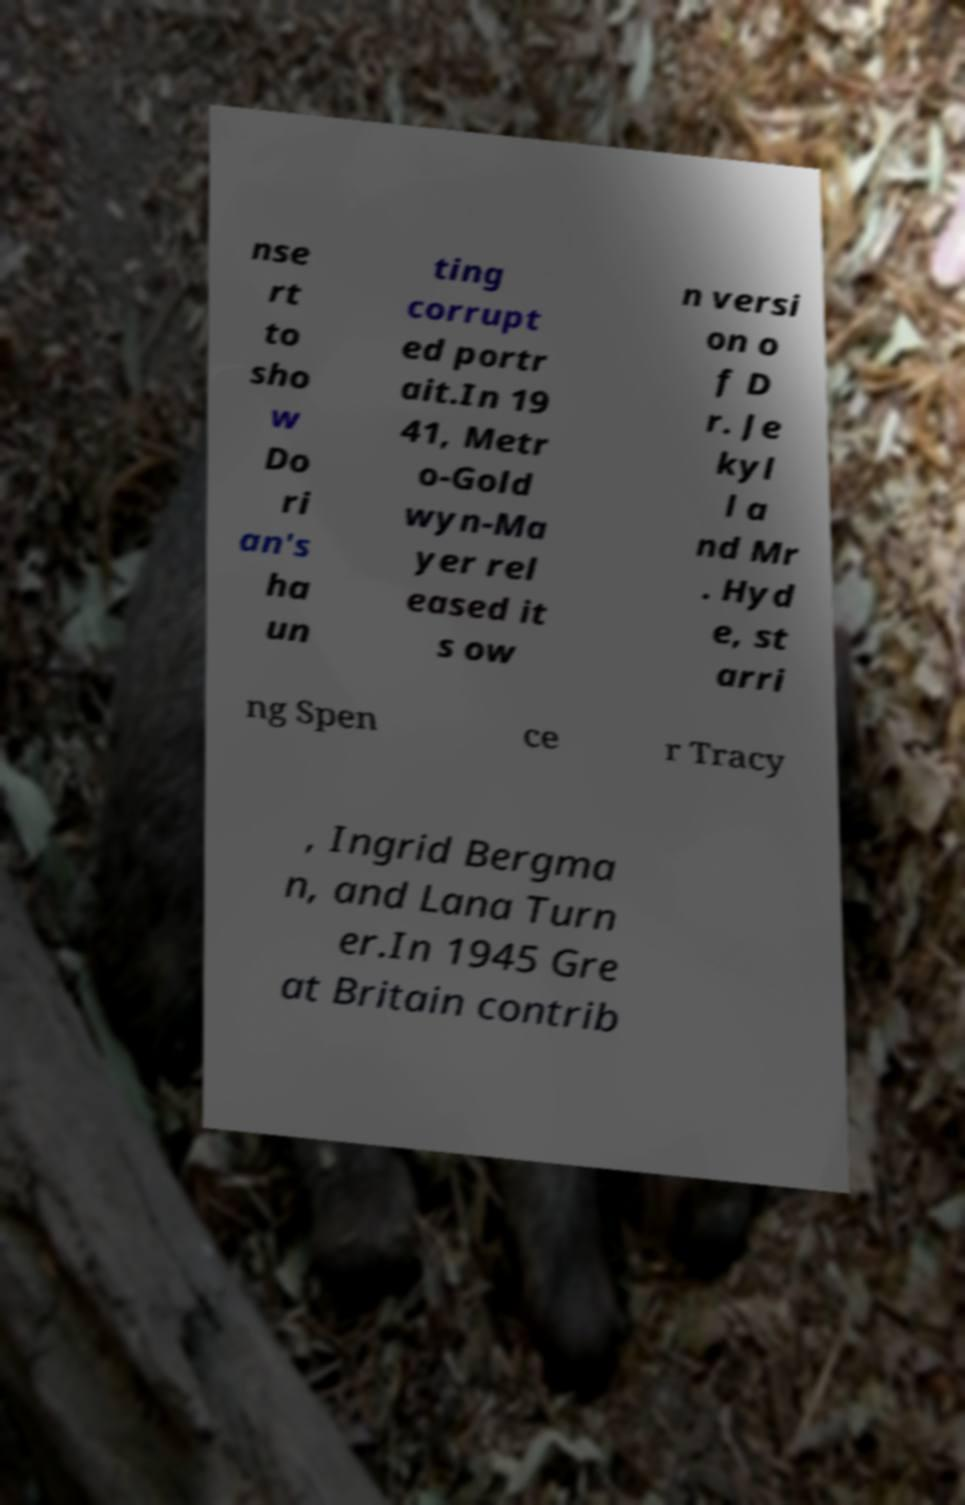I need the written content from this picture converted into text. Can you do that? nse rt to sho w Do ri an's ha un ting corrupt ed portr ait.In 19 41, Metr o-Gold wyn-Ma yer rel eased it s ow n versi on o f D r. Je kyl l a nd Mr . Hyd e, st arri ng Spen ce r Tracy , Ingrid Bergma n, and Lana Turn er.In 1945 Gre at Britain contrib 